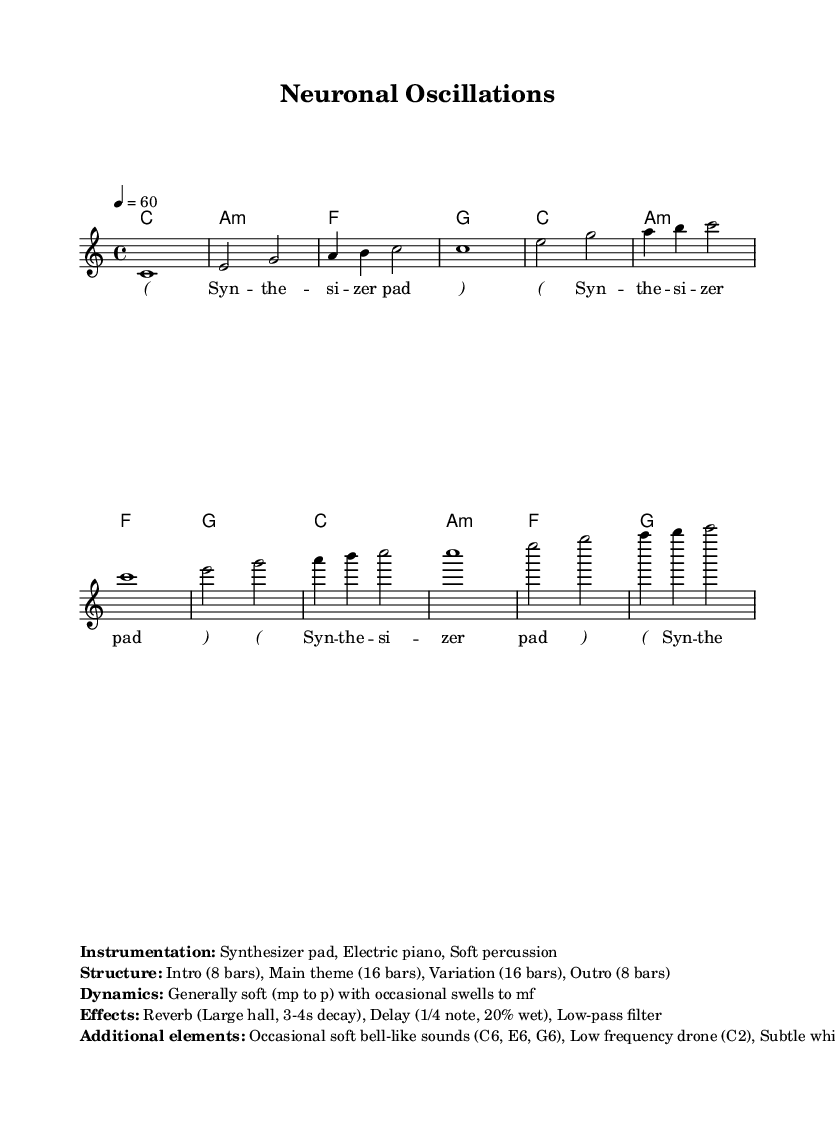What is the key signature of this music? The key signature is C major, which has no sharps or flats indicated on the staff.
Answer: C major What is the time signature of this piece? The time signature is shown as 4/4, which means there are four beats in each measure, and the quarter note gets one beat.
Answer: 4/4 What is the tempo marking for this composition? The tempo marking is indicated by the number "60" which means the piece is to be played at 60 beats per minute.
Answer: 60 How many bars are there in the main theme? The main theme is specified to comprise 16 bars, which can be found in the structure provided in the markup section.
Answer: 16 What instrumentation is used in this piece? The music sheet details three instruments: Synthesizer pad, Electric piano, and Soft percussion, listed under "Instrumentation."
Answer: Synthesizer pad, Electric piano, Soft percussion What dynamic range is indicated for the piece? The dynamic range mentioned describes the general level, which is from mezzo-piano to piano with occasional swells to mezzo-forte, as indicated in the dynamics.
Answer: mp to p, swells to mf What additional elements are included in the soundscape? The additional elements include soft bell-like sounds and a low frequency drone, which are listed in the markup section describing effects and textures.
Answer: Soft bell-like sounds, low frequency drone 